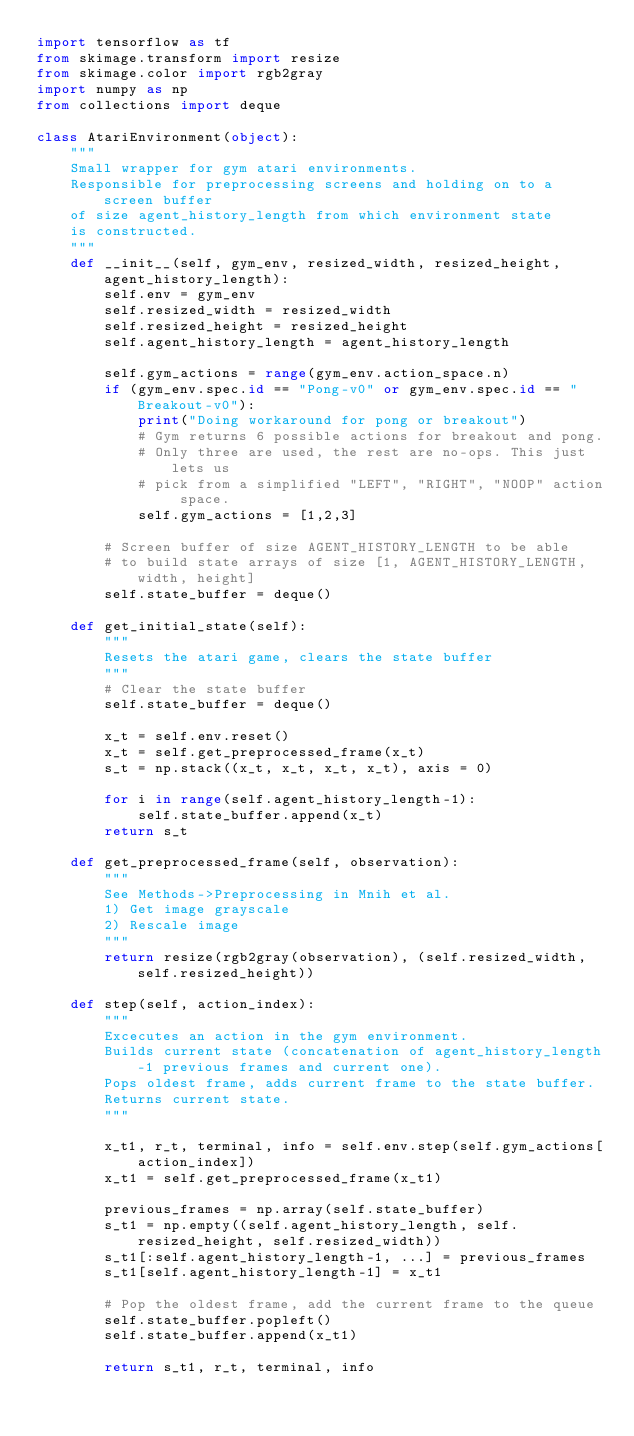Convert code to text. <code><loc_0><loc_0><loc_500><loc_500><_Python_>import tensorflow as tf
from skimage.transform import resize
from skimage.color import rgb2gray
import numpy as np
from collections import deque

class AtariEnvironment(object):
    """
    Small wrapper for gym atari environments.
    Responsible for preprocessing screens and holding on to a screen buffer 
    of size agent_history_length from which environment state
    is constructed.
    """
    def __init__(self, gym_env, resized_width, resized_height, agent_history_length):
        self.env = gym_env
        self.resized_width = resized_width
        self.resized_height = resized_height
        self.agent_history_length = agent_history_length

        self.gym_actions = range(gym_env.action_space.n)
        if (gym_env.spec.id == "Pong-v0" or gym_env.spec.id == "Breakout-v0"):
            print("Doing workaround for pong or breakout")
            # Gym returns 6 possible actions for breakout and pong.
            # Only three are used, the rest are no-ops. This just lets us
            # pick from a simplified "LEFT", "RIGHT", "NOOP" action space.
            self.gym_actions = [1,2,3]

        # Screen buffer of size AGENT_HISTORY_LENGTH to be able
        # to build state arrays of size [1, AGENT_HISTORY_LENGTH, width, height]
        self.state_buffer = deque()

    def get_initial_state(self):
        """
        Resets the atari game, clears the state buffer
        """
        # Clear the state buffer
        self.state_buffer = deque()

        x_t = self.env.reset()
        x_t = self.get_preprocessed_frame(x_t)
        s_t = np.stack((x_t, x_t, x_t, x_t), axis = 0)
        
        for i in range(self.agent_history_length-1):
            self.state_buffer.append(x_t)
        return s_t

    def get_preprocessed_frame(self, observation):
        """
        See Methods->Preprocessing in Mnih et al.
        1) Get image grayscale
        2) Rescale image
        """
        return resize(rgb2gray(observation), (self.resized_width, self.resized_height))

    def step(self, action_index):
        """
        Excecutes an action in the gym environment.
        Builds current state (concatenation of agent_history_length-1 previous frames and current one).
        Pops oldest frame, adds current frame to the state buffer.
        Returns current state.
        """

        x_t1, r_t, terminal, info = self.env.step(self.gym_actions[action_index])
        x_t1 = self.get_preprocessed_frame(x_t1)

        previous_frames = np.array(self.state_buffer)
        s_t1 = np.empty((self.agent_history_length, self.resized_height, self.resized_width))
        s_t1[:self.agent_history_length-1, ...] = previous_frames
        s_t1[self.agent_history_length-1] = x_t1

        # Pop the oldest frame, add the current frame to the queue
        self.state_buffer.popleft()
        self.state_buffer.append(x_t1)

        return s_t1, r_t, terminal, info
</code> 